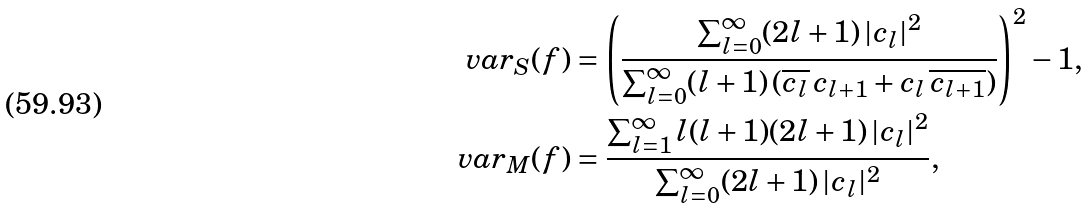<formula> <loc_0><loc_0><loc_500><loc_500>\text {var} _ { S } ( f ) & = \left ( \frac { \sum _ { l = 0 } ^ { \infty } ( 2 l + 1 ) \, | c _ { l } | ^ { 2 } } { \sum _ { l = 0 } ^ { \infty } ( l + 1 ) \, ( \overline { c _ { l } } \, c _ { l + 1 } + c _ { l } \, \overline { c _ { l + 1 } } ) } \right ) ^ { 2 } - 1 , \\ \text {var} _ { M } ( f ) & = \frac { \sum _ { l = 1 } ^ { \infty } l ( l + 1 ) ( 2 l + 1 ) \, | c _ { l } | ^ { 2 } } { \sum _ { l = 0 } ^ { \infty } ( 2 l + 1 ) \, | c _ { l } | ^ { 2 } } ,</formula> 